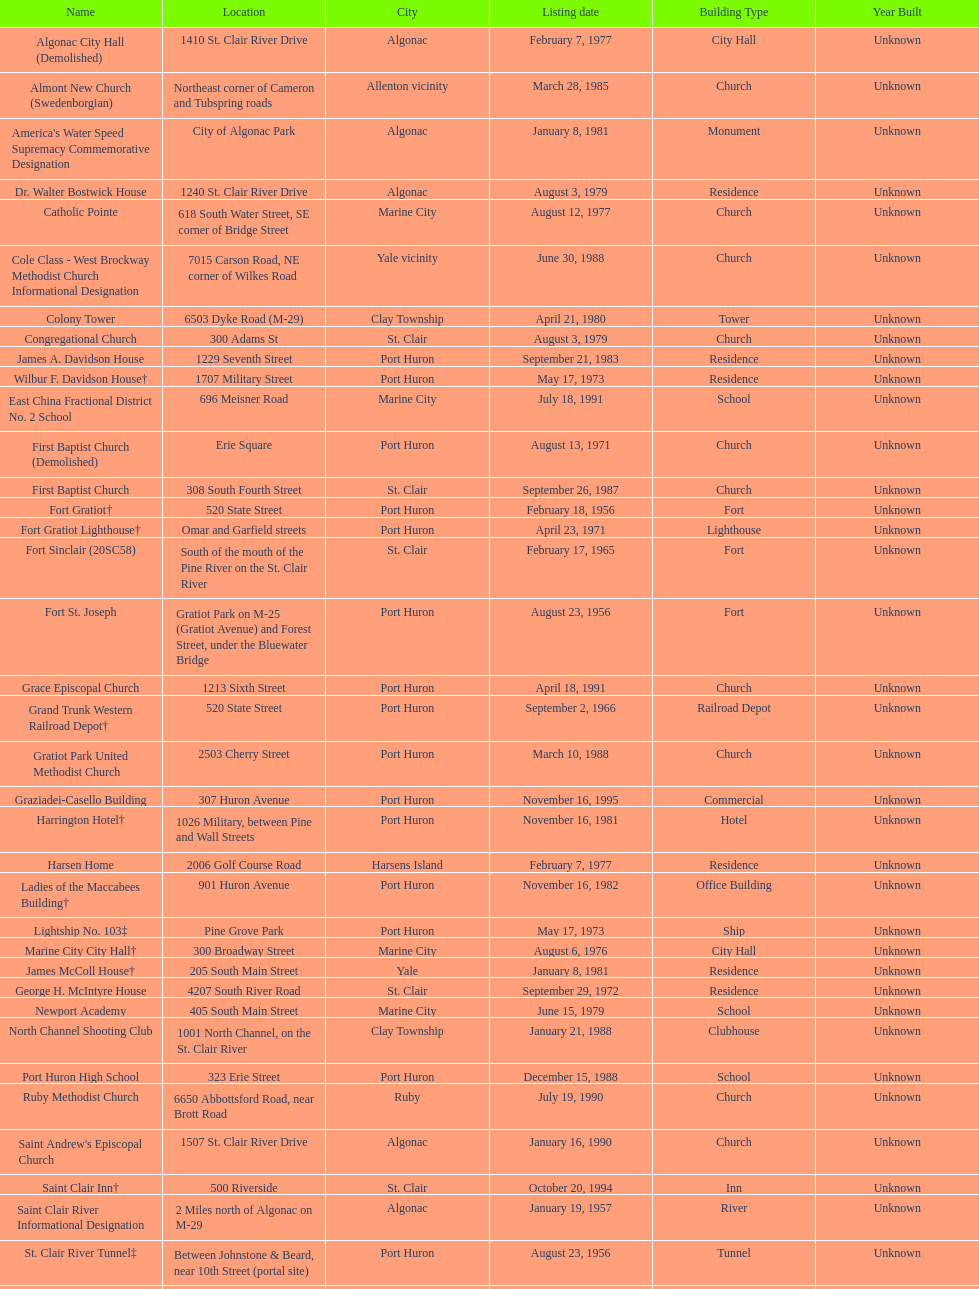How many names do not have images next to them? 41. 